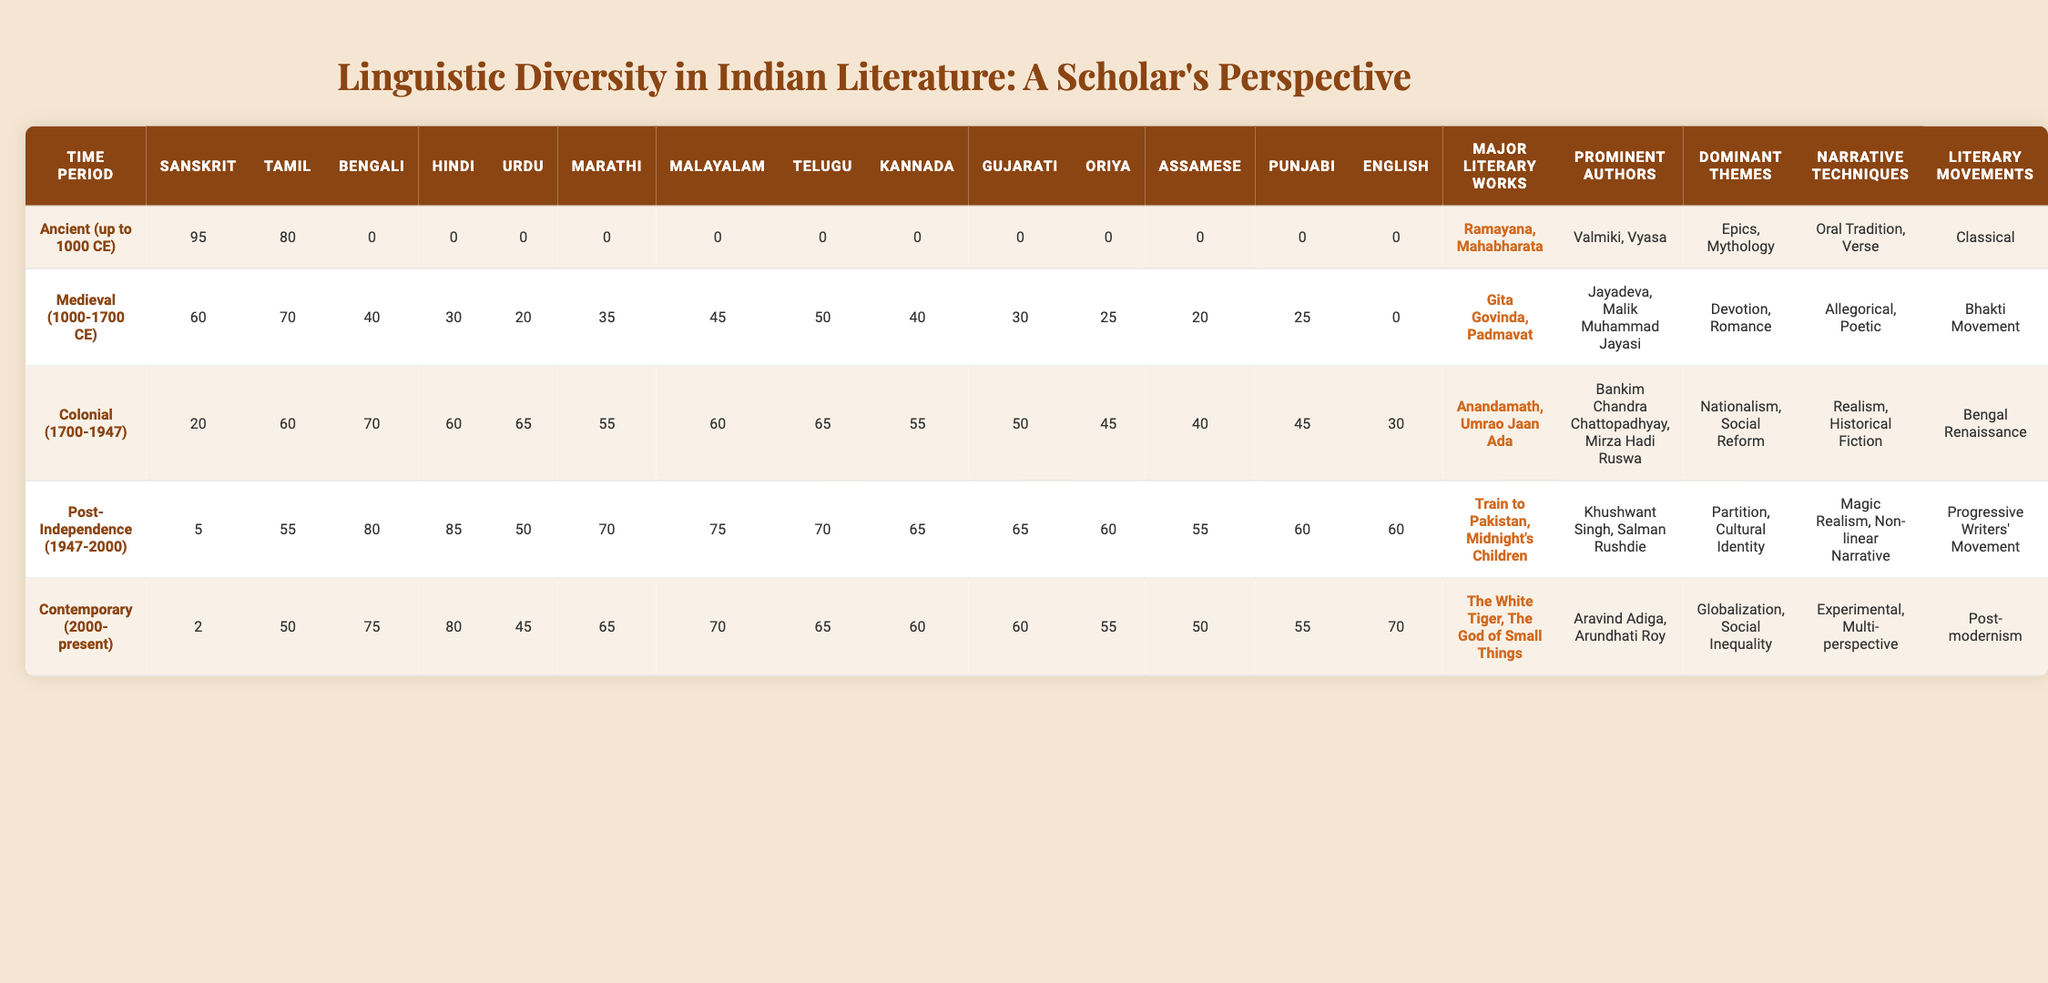What were the major literary works produced during the Colonial period? According to the table, the major literary works produced during the Colonial period (1700-1947) include "Anandamath" and "Umrao Jaan Ada."
Answer: Anandamath, Umrao Jaan Ada What is the total count of literary works represented in Sanskrit across different periods? By reviewing the Sanskrit column for each period, the total count is 95 + 60 + 20 + 5 + 2 = 182.
Answer: 182 Which language has the highest representation in literature during the Ancient period? The Sanskrit column shows a value of 95, which is the highest among all languages in the Ancient period.
Answer: Sanskrit How did the representation of Hindi literature change from the Medieval to the Post-Independence period? The representation of Hindi literature increased from 30 in the Medieval period to 85 in the Post-Independence period, indicating a growth of 55 units.
Answer: Increased by 55 Is there any language that was not represented in the Ancient period? Yes, the table shows that all languages except Sanskrit had a representation of 0 in the Ancient period, confirming that no other language was represented.
Answer: Yes Which time period saw the highest diversity in literary languages? The Post-Independence period shows values for 14 languages, indicating high diversity; no other period has higher representation in languages.
Answer: Post-Independence What is the dominant theme associated with literature in the Contemporary period? The table indicates that the dominant theme during the Contemporary period (2000-present) is "Globalization, Social Inequality."
Answer: Globalization, Social Inequality Compare the average representation of Tamil literature in Medieval and Contemporary periods. In Medieval, the Tamil representation is 70, and in Contemporary, it is 50. The average is (70 + 50) / 2 = 60.
Answer: 60 Is the narrative technique of “Magic Realism” present in the Medieval period? The table specifies that "Magic Realism" as a narrative technique is only associated with the Post-Independence and Contemporary periods, but not the Medieval period.
Answer: No Which literary movement corresponds with a significant increase in Bengali literature from the Colonial to the Post-Independence periods? The table shows an increase from 70 in the Colonial period to 80 in the Post-Independence period, associated with the Bengal Renaissance movement.
Answer: Bengal Renaissance 